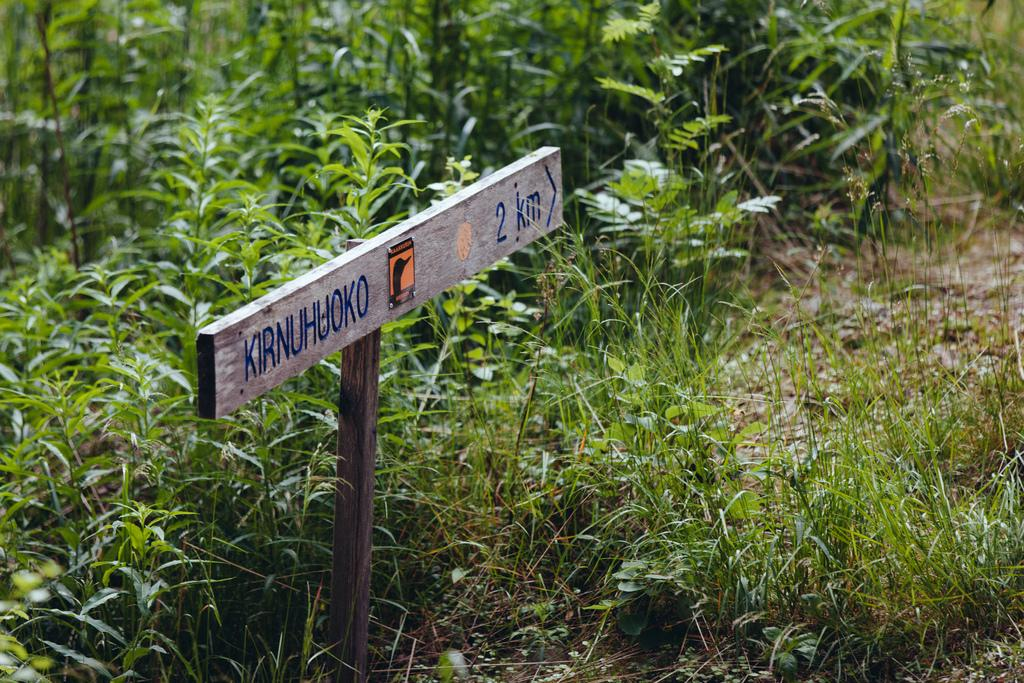What is written on the signboard in the image? The image contains a signboard with text, but the specific text is not mentioned in the facts provided. What type of plants can be seen in the image? There are plants in the image, but their specific type is not mentioned in the facts provided. What is the ground covered with in the image? The ground is covered with grass in the image. How many times does the person in the image use their mouth to shake a screw? There is no person present in the image, and therefore no such activity can be observed. 